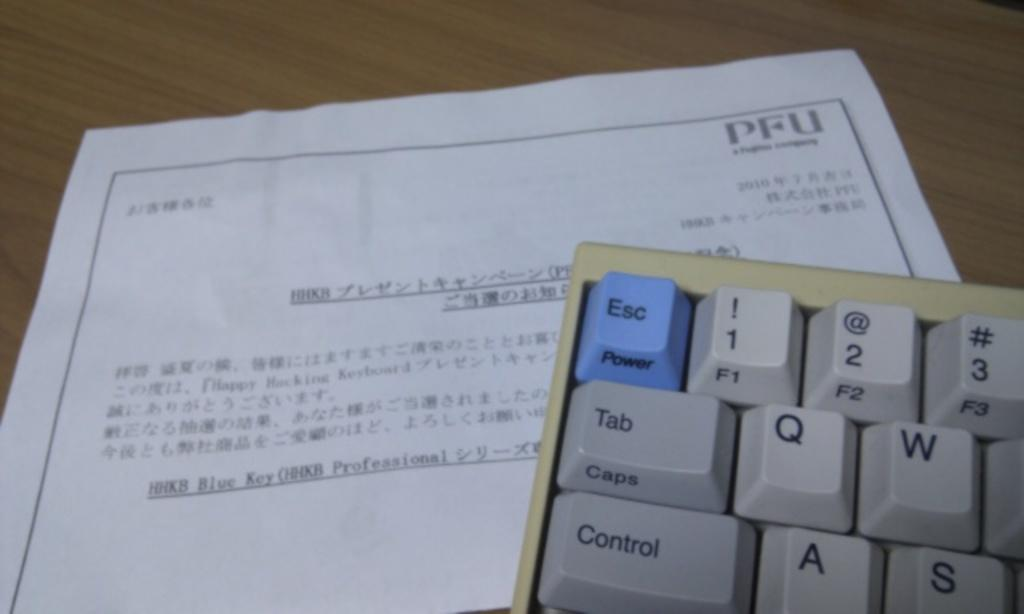<image>
Render a clear and concise summary of the photo. Corner of a keyboard with the Esc key reading power and is blue 